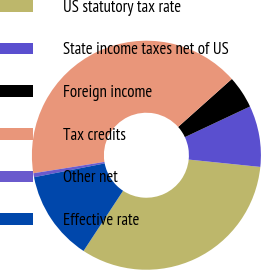<chart> <loc_0><loc_0><loc_500><loc_500><pie_chart><fcel>US statutory tax rate<fcel>State income taxes net of US<fcel>Foreign income<fcel>Tax credits<fcel>Other net<fcel>Effective rate<nl><fcel>32.62%<fcel>8.63%<fcel>4.6%<fcel>40.92%<fcel>0.56%<fcel>12.67%<nl></chart> 